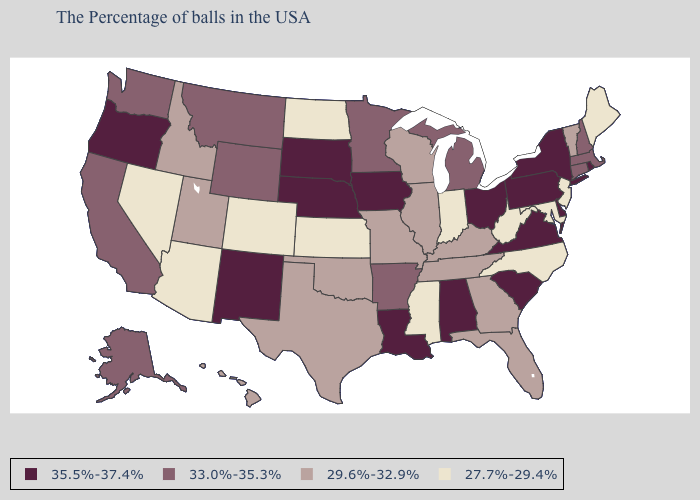What is the highest value in the South ?
Short answer required. 35.5%-37.4%. What is the lowest value in the South?
Write a very short answer. 27.7%-29.4%. Which states have the lowest value in the MidWest?
Concise answer only. Indiana, Kansas, North Dakota. What is the value of Illinois?
Write a very short answer. 29.6%-32.9%. Name the states that have a value in the range 33.0%-35.3%?
Answer briefly. Massachusetts, New Hampshire, Connecticut, Michigan, Arkansas, Minnesota, Wyoming, Montana, California, Washington, Alaska. Name the states that have a value in the range 27.7%-29.4%?
Concise answer only. Maine, New Jersey, Maryland, North Carolina, West Virginia, Indiana, Mississippi, Kansas, North Dakota, Colorado, Arizona, Nevada. Does Arizona have the lowest value in the West?
Concise answer only. Yes. Which states have the highest value in the USA?
Keep it brief. Rhode Island, New York, Delaware, Pennsylvania, Virginia, South Carolina, Ohio, Alabama, Louisiana, Iowa, Nebraska, South Dakota, New Mexico, Oregon. Name the states that have a value in the range 27.7%-29.4%?
Give a very brief answer. Maine, New Jersey, Maryland, North Carolina, West Virginia, Indiana, Mississippi, Kansas, North Dakota, Colorado, Arizona, Nevada. Does Iowa have the highest value in the MidWest?
Write a very short answer. Yes. What is the lowest value in the USA?
Short answer required. 27.7%-29.4%. Does New Jersey have the highest value in the Northeast?
Short answer required. No. Name the states that have a value in the range 27.7%-29.4%?
Write a very short answer. Maine, New Jersey, Maryland, North Carolina, West Virginia, Indiana, Mississippi, Kansas, North Dakota, Colorado, Arizona, Nevada. Name the states that have a value in the range 27.7%-29.4%?
Concise answer only. Maine, New Jersey, Maryland, North Carolina, West Virginia, Indiana, Mississippi, Kansas, North Dakota, Colorado, Arizona, Nevada. Among the states that border Massachusetts , which have the lowest value?
Answer briefly. Vermont. 